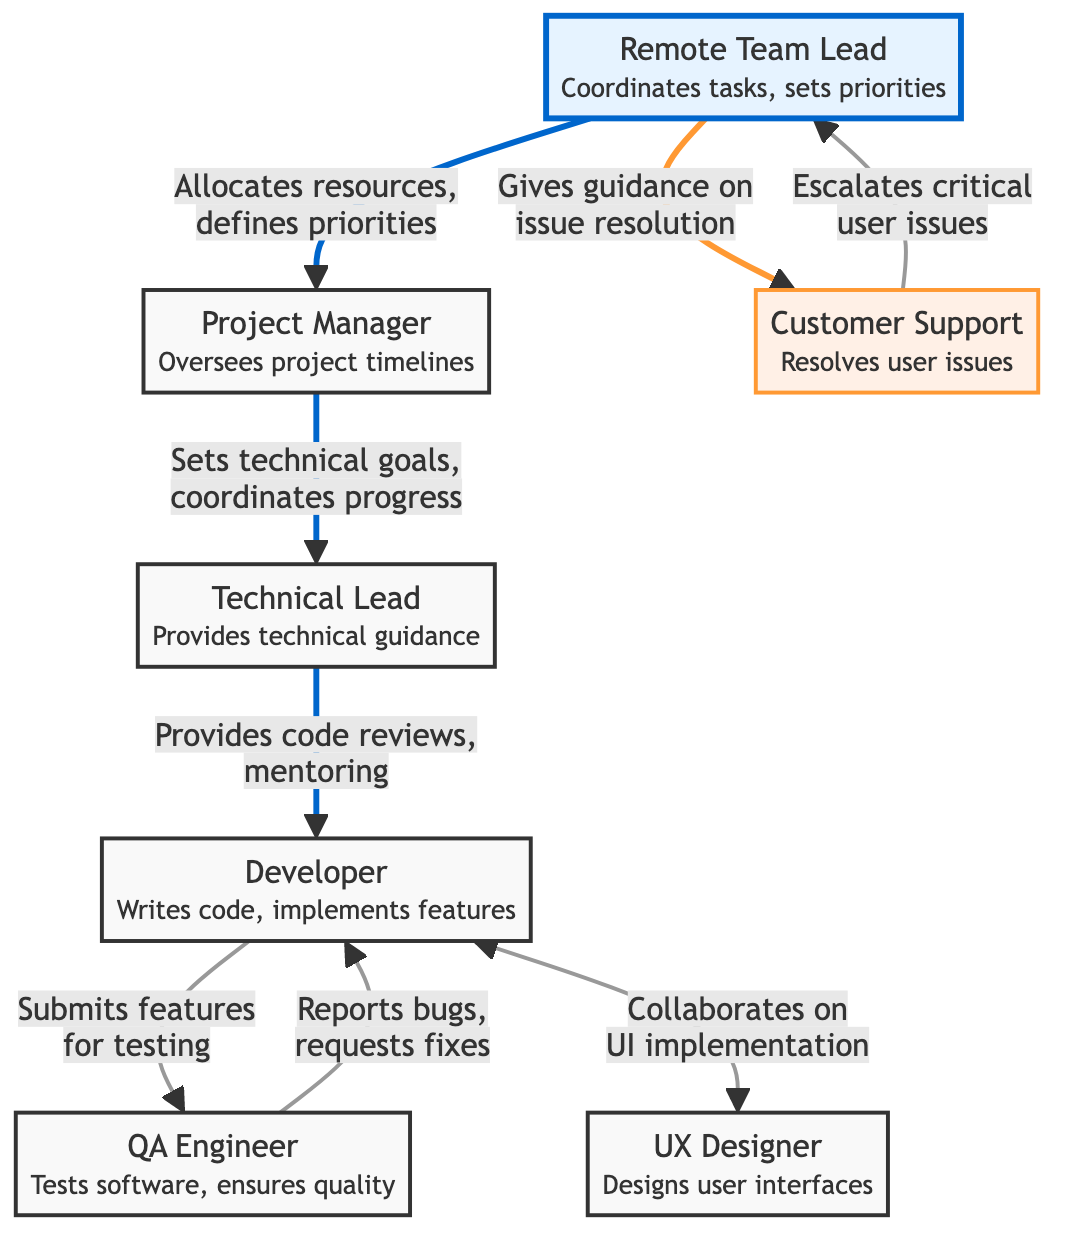What's the role of the Remote Team Lead? The Remote Team Lead is responsible for coordinating tasks and setting priorities within the team. This is indicated in the diagram next to the Remote Team Lead node and defines their main contribution to the team structure.
Answer: Coordinates tasks, sets priorities Who does the Project Manager report to? In the diagram, the flow shows an arrow pointing from the Project Manager to the Technical Lead, which indicates that the Project Manager coordinates progress and sets technical goals with the Technical Lead. Therefore, the Project Manager reports to the Remote Team Lead.
Answer: Remote Team Lead How many support roles are present in the diagram? The diagram shows only one role categorized as a support role, which is the Customer Support node, as indicated by the color coding (orange fill). Thus, there is only one support role illustrated in the diagram.
Answer: 1 What is the main function of the QA Engineer? The primary function of the QA Engineer is to test the software and ensure its quality, which is stated directly next to the QA Engineer node in the diagram.
Answer: Tests software, ensures quality Who escalates critical user issues to the Remote Team Lead? According to the diagram, the arrow from the Customer Support node connects to the Remote Team Lead, indicating that Customer Support is responsible for escalating critical user issues. This flow illustrates the communication routing in the team.
Answer: Customer Support Which role collaborates on UI implementation? The flow between the Developer and UX Designer nodes in the diagram indicates that these two roles work together specifically on UI implementation tasks, as both nodes have arrows pointing toward each other.
Answer: Developer, UX Designer What guidance does the Remote Team Lead provide to Customer Support? The diagram shows an arrow pointing from the Remote Team Lead to Customer Support with a description that states the Remote Team Lead gives guidance on issue resolution, suggesting that they offer support in solving problems escalated by Customer Support.
Answer: Guidance on issue resolution How many nodes are in the diagram? The diagram contains a total of seven nodes representing different roles in the remote team, which includes the Remote Team Lead, Project Manager, Technical Lead, Developer, QA Engineer, UX Designer, and Customer Support. Counting these nodes confirms the total number.
Answer: 7 What type of relationship exists between the Developer and QA Engineer? The diagram illustrates a two-way relationship between the Developer and QA Engineer nodes, indicated by a bidirectional arrow, representing their collaborative interactions in the implementation and testing processes.
Answer: Collaborative relationship 